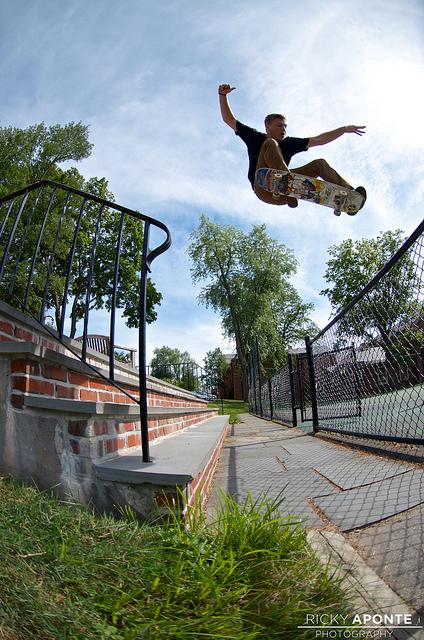Is the man doing a trick?
Be succinct. Yes. What is the man wearing?
Concise answer only. Clothes. What kind of stair railing is that?
Be succinct. Metal. How many steps are there?
Give a very brief answer. 4. Is he going to fall?
Write a very short answer. Yes. 